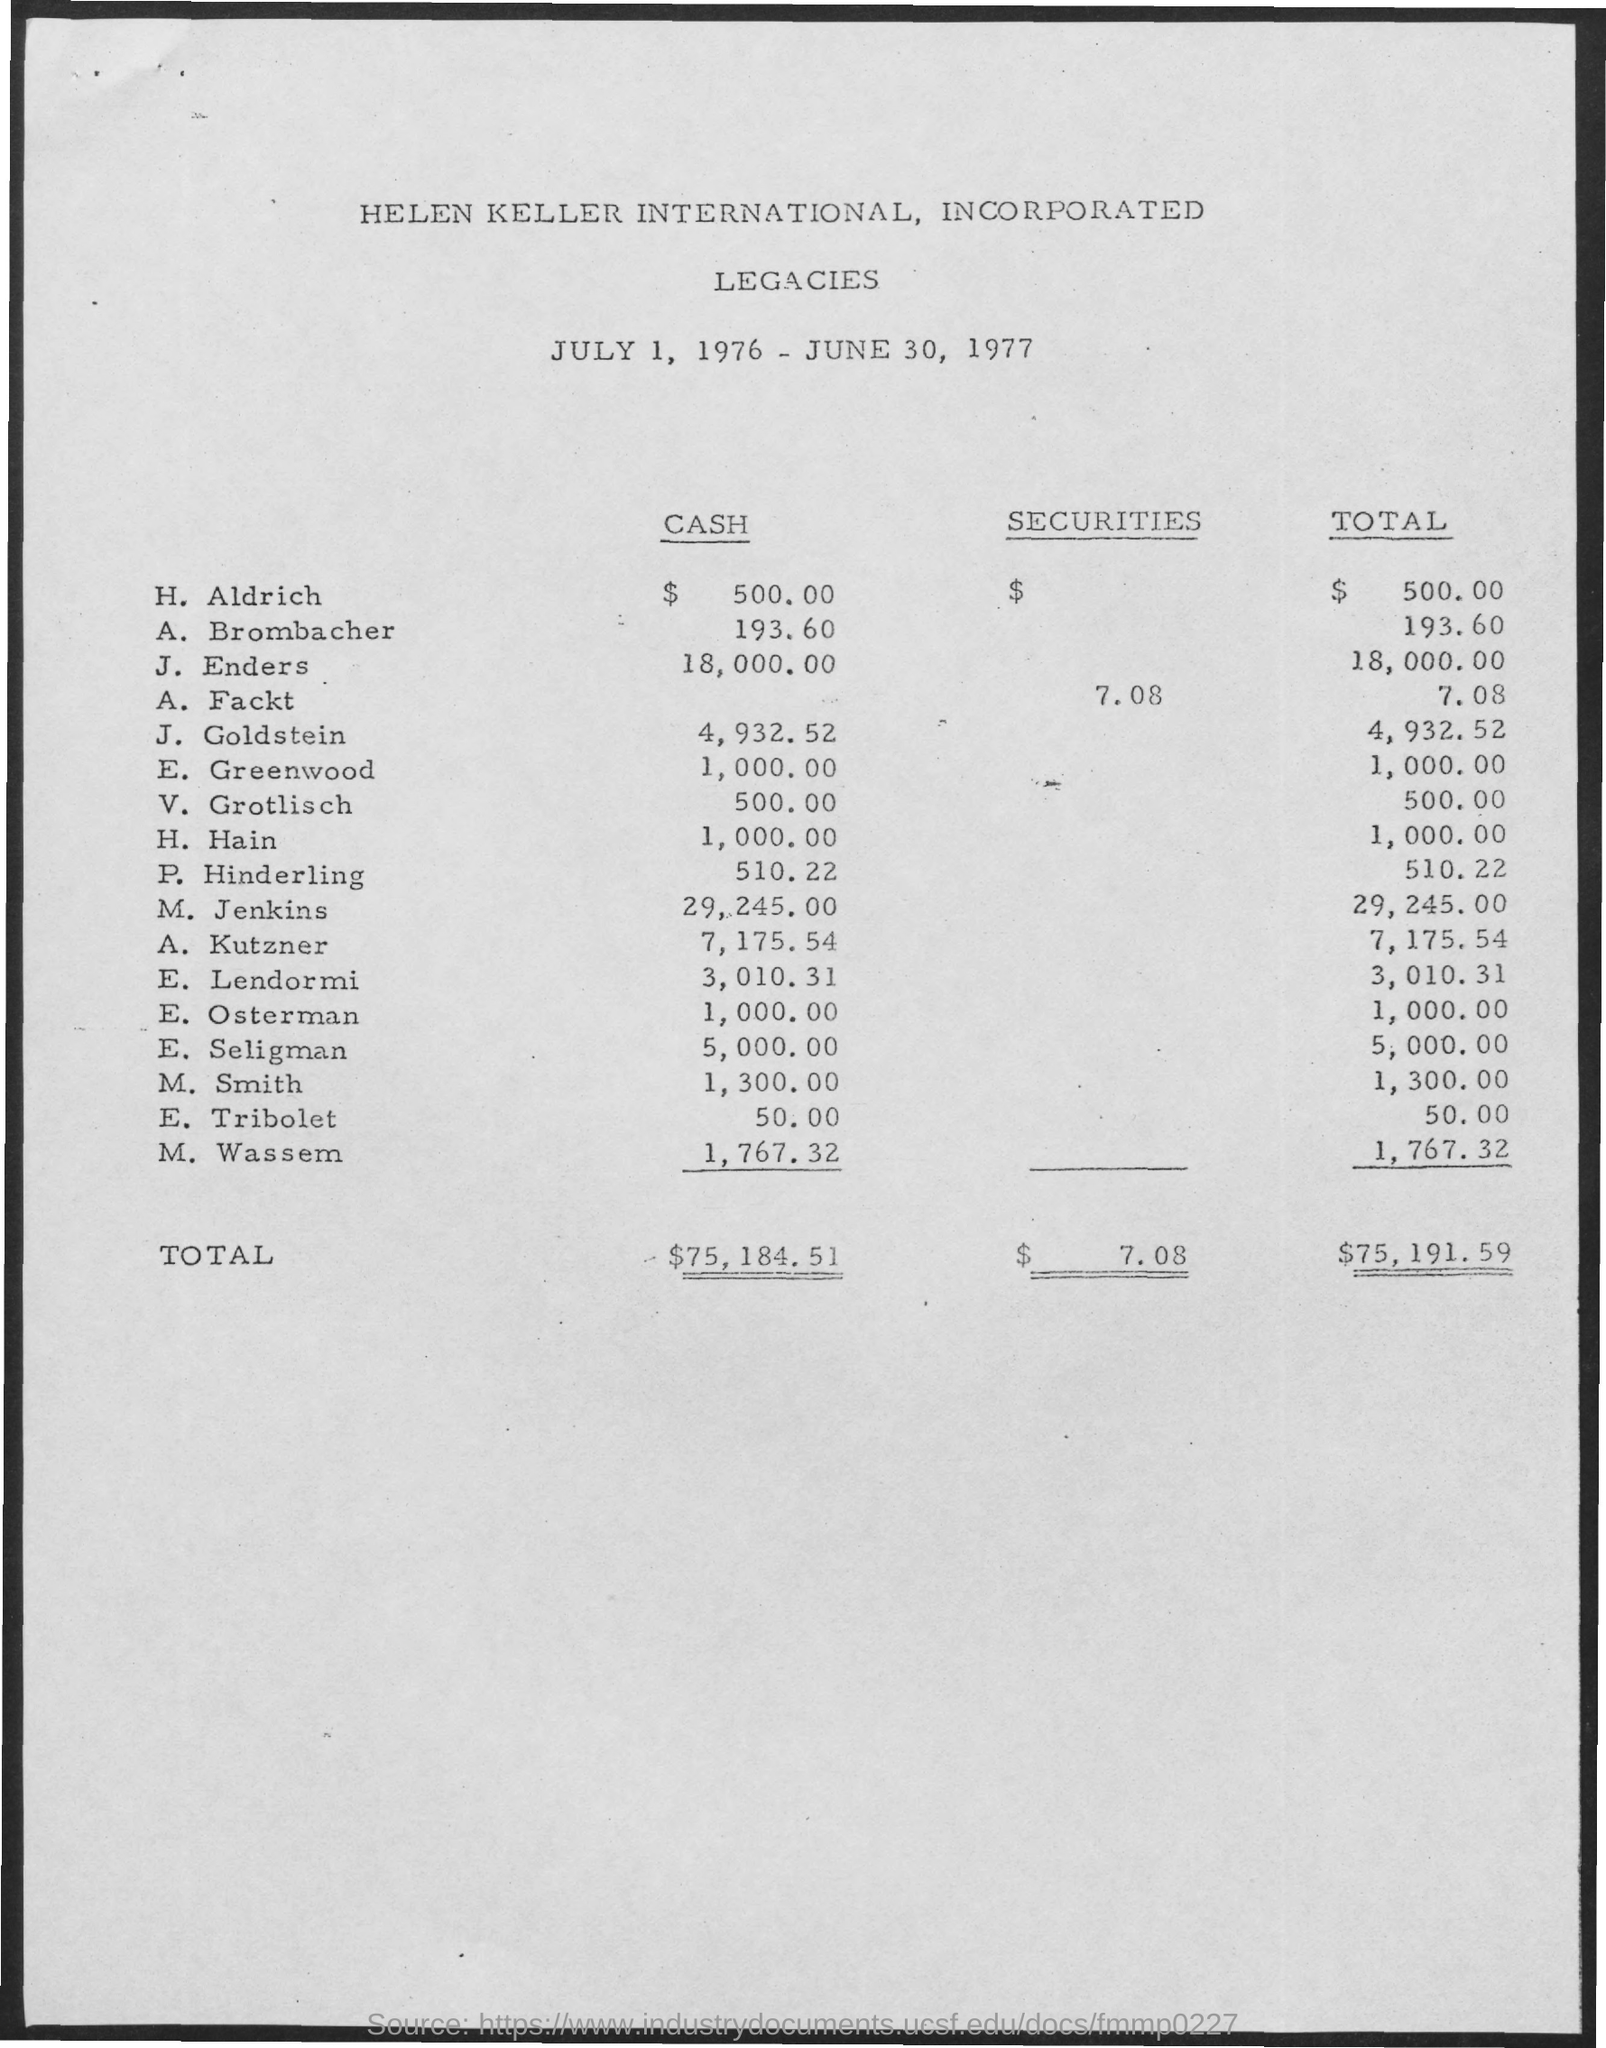What is the Total for H. Aldrich?
Your answer should be compact. $ 500.00. What is the Total for A. Brombacher?
Make the answer very short. 193.60. What is the Total for J. Enders?
Ensure brevity in your answer.  18,000.00. What is the Total for A. Fackt?
Provide a short and direct response. 7.08. What is the Total for J. Goldstein?
Ensure brevity in your answer.  4,932.52. What is the Total for H. Hain?
Keep it short and to the point. 1,000.00. What is the Total Cash?
Keep it short and to the point. $75,184.51. What is the Total Securities?
Offer a very short reply. $ 7.08. 